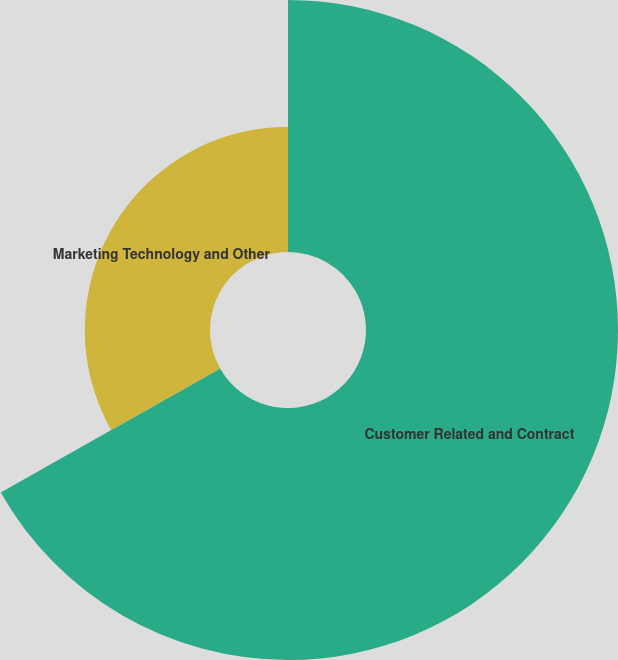Convert chart. <chart><loc_0><loc_0><loc_500><loc_500><pie_chart><fcel>Customer Related and Contract<fcel>Marketing Technology and Other<nl><fcel>66.81%<fcel>33.19%<nl></chart> 